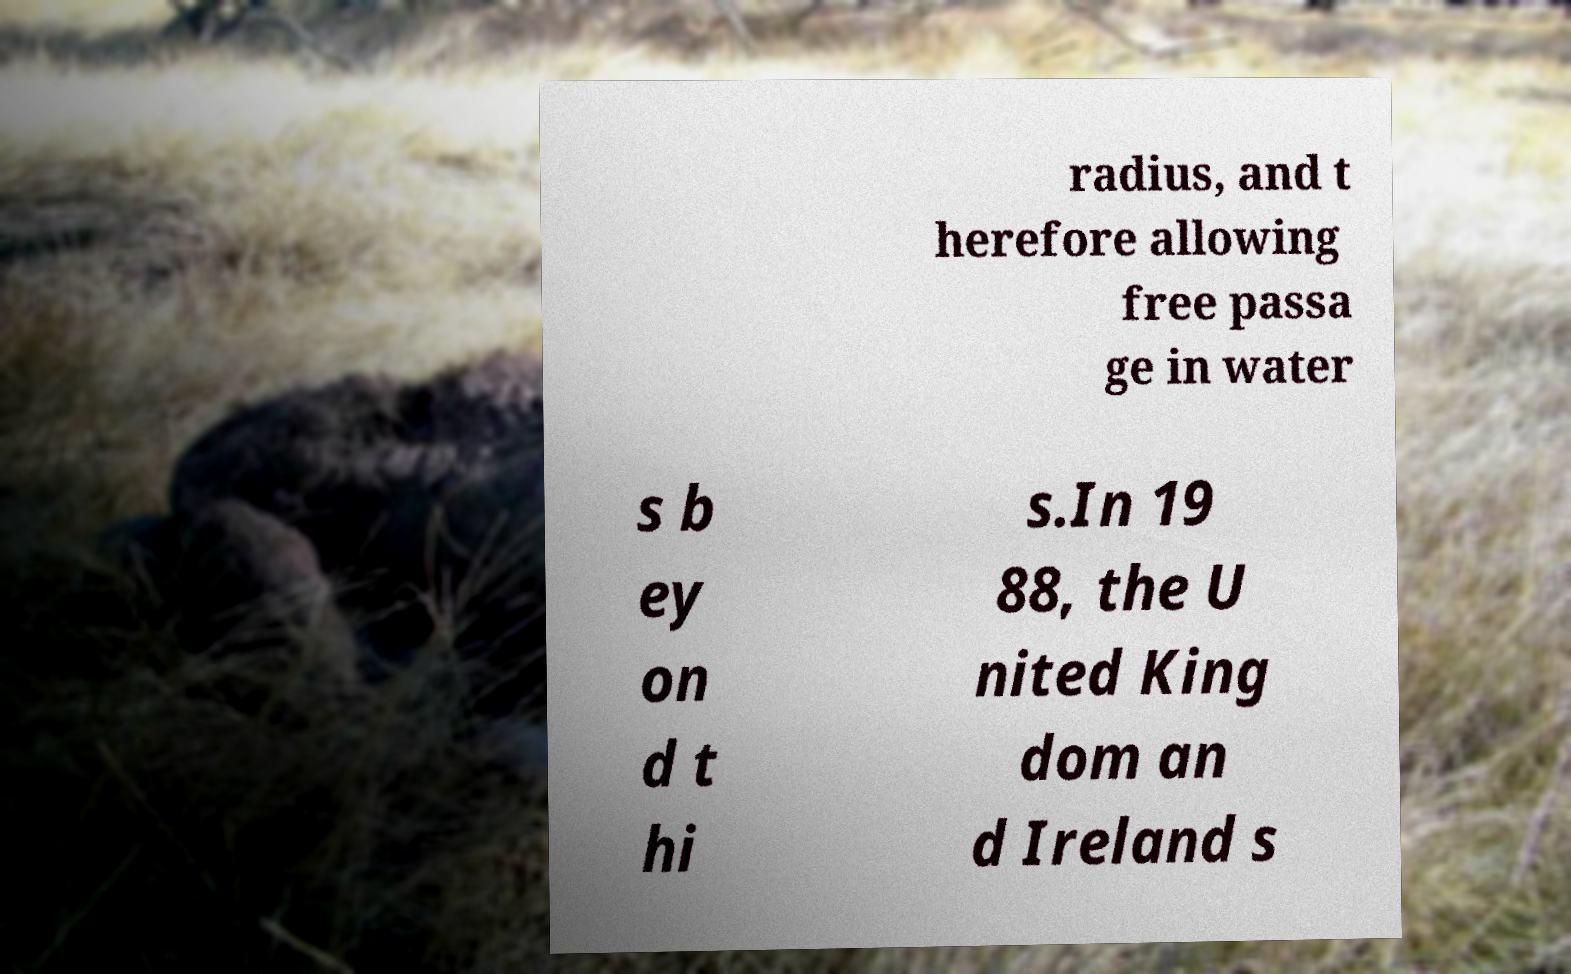Could you extract and type out the text from this image? radius, and t herefore allowing free passa ge in water s b ey on d t hi s.In 19 88, the U nited King dom an d Ireland s 